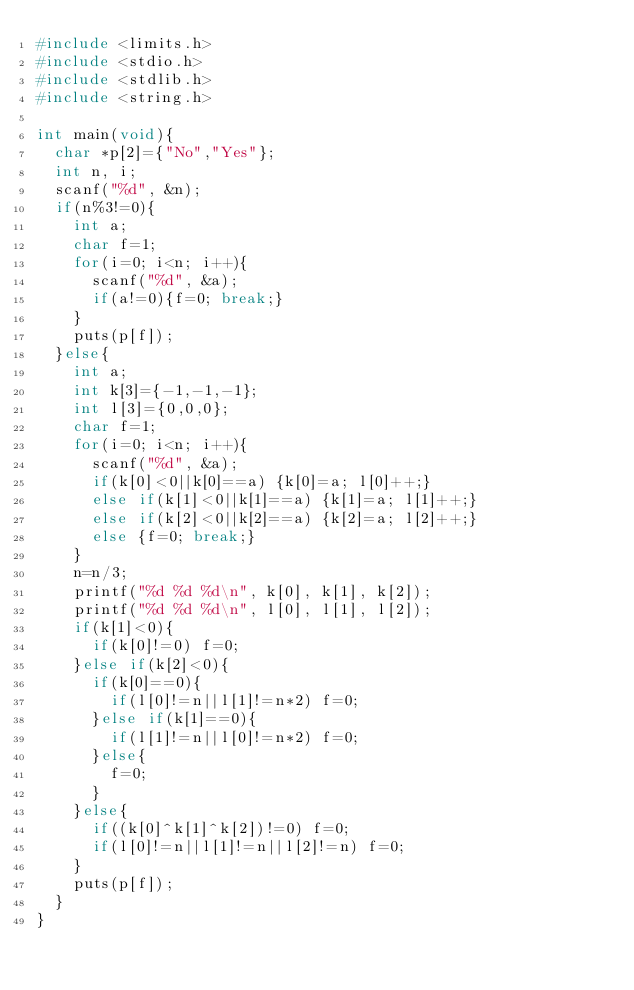Convert code to text. <code><loc_0><loc_0><loc_500><loc_500><_C_>#include <limits.h>
#include <stdio.h>
#include <stdlib.h>
#include <string.h>

int main(void){
	char *p[2]={"No","Yes"};
	int n, i;
	scanf("%d", &n);
	if(n%3!=0){
		int a;
		char f=1;
		for(i=0; i<n; i++){
			scanf("%d", &a);
			if(a!=0){f=0; break;}
		}
		puts(p[f]);
	}else{
		int a;
		int k[3]={-1,-1,-1};
		int l[3]={0,0,0};
		char f=1;
		for(i=0; i<n; i++){
			scanf("%d", &a);
			if(k[0]<0||k[0]==a) {k[0]=a; l[0]++;}
			else if(k[1]<0||k[1]==a) {k[1]=a; l[1]++;}
			else if(k[2]<0||k[2]==a) {k[2]=a; l[2]++;}
			else {f=0; break;}
		}
		n=n/3;
		printf("%d %d %d\n", k[0], k[1], k[2]);
		printf("%d %d %d\n", l[0], l[1], l[2]);
		if(k[1]<0){
			if(k[0]!=0) f=0;
		}else if(k[2]<0){
			if(k[0]==0){
				if(l[0]!=n||l[1]!=n*2) f=0;
			}else if(k[1]==0){
				if(l[1]!=n||l[0]!=n*2) f=0;
			}else{
				f=0;
			}
		}else{
			if((k[0]^k[1]^k[2])!=0) f=0;
			if(l[0]!=n||l[1]!=n||l[2]!=n) f=0;
		}
		puts(p[f]);
	}
}

</code> 